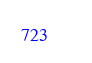Convert code to text. <code><loc_0><loc_0><loc_500><loc_500><_Nim_>





















</code> 